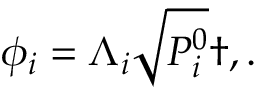Convert formula to latex. <formula><loc_0><loc_0><loc_500><loc_500>\phi _ { i } = \Lambda _ { i } \sqrt { P _ { i } ^ { 0 } } \dag , .</formula> 